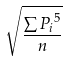<formula> <loc_0><loc_0><loc_500><loc_500>\sqrt { \frac { \sum { P _ { i } } ^ { 5 } } { n } }</formula> 